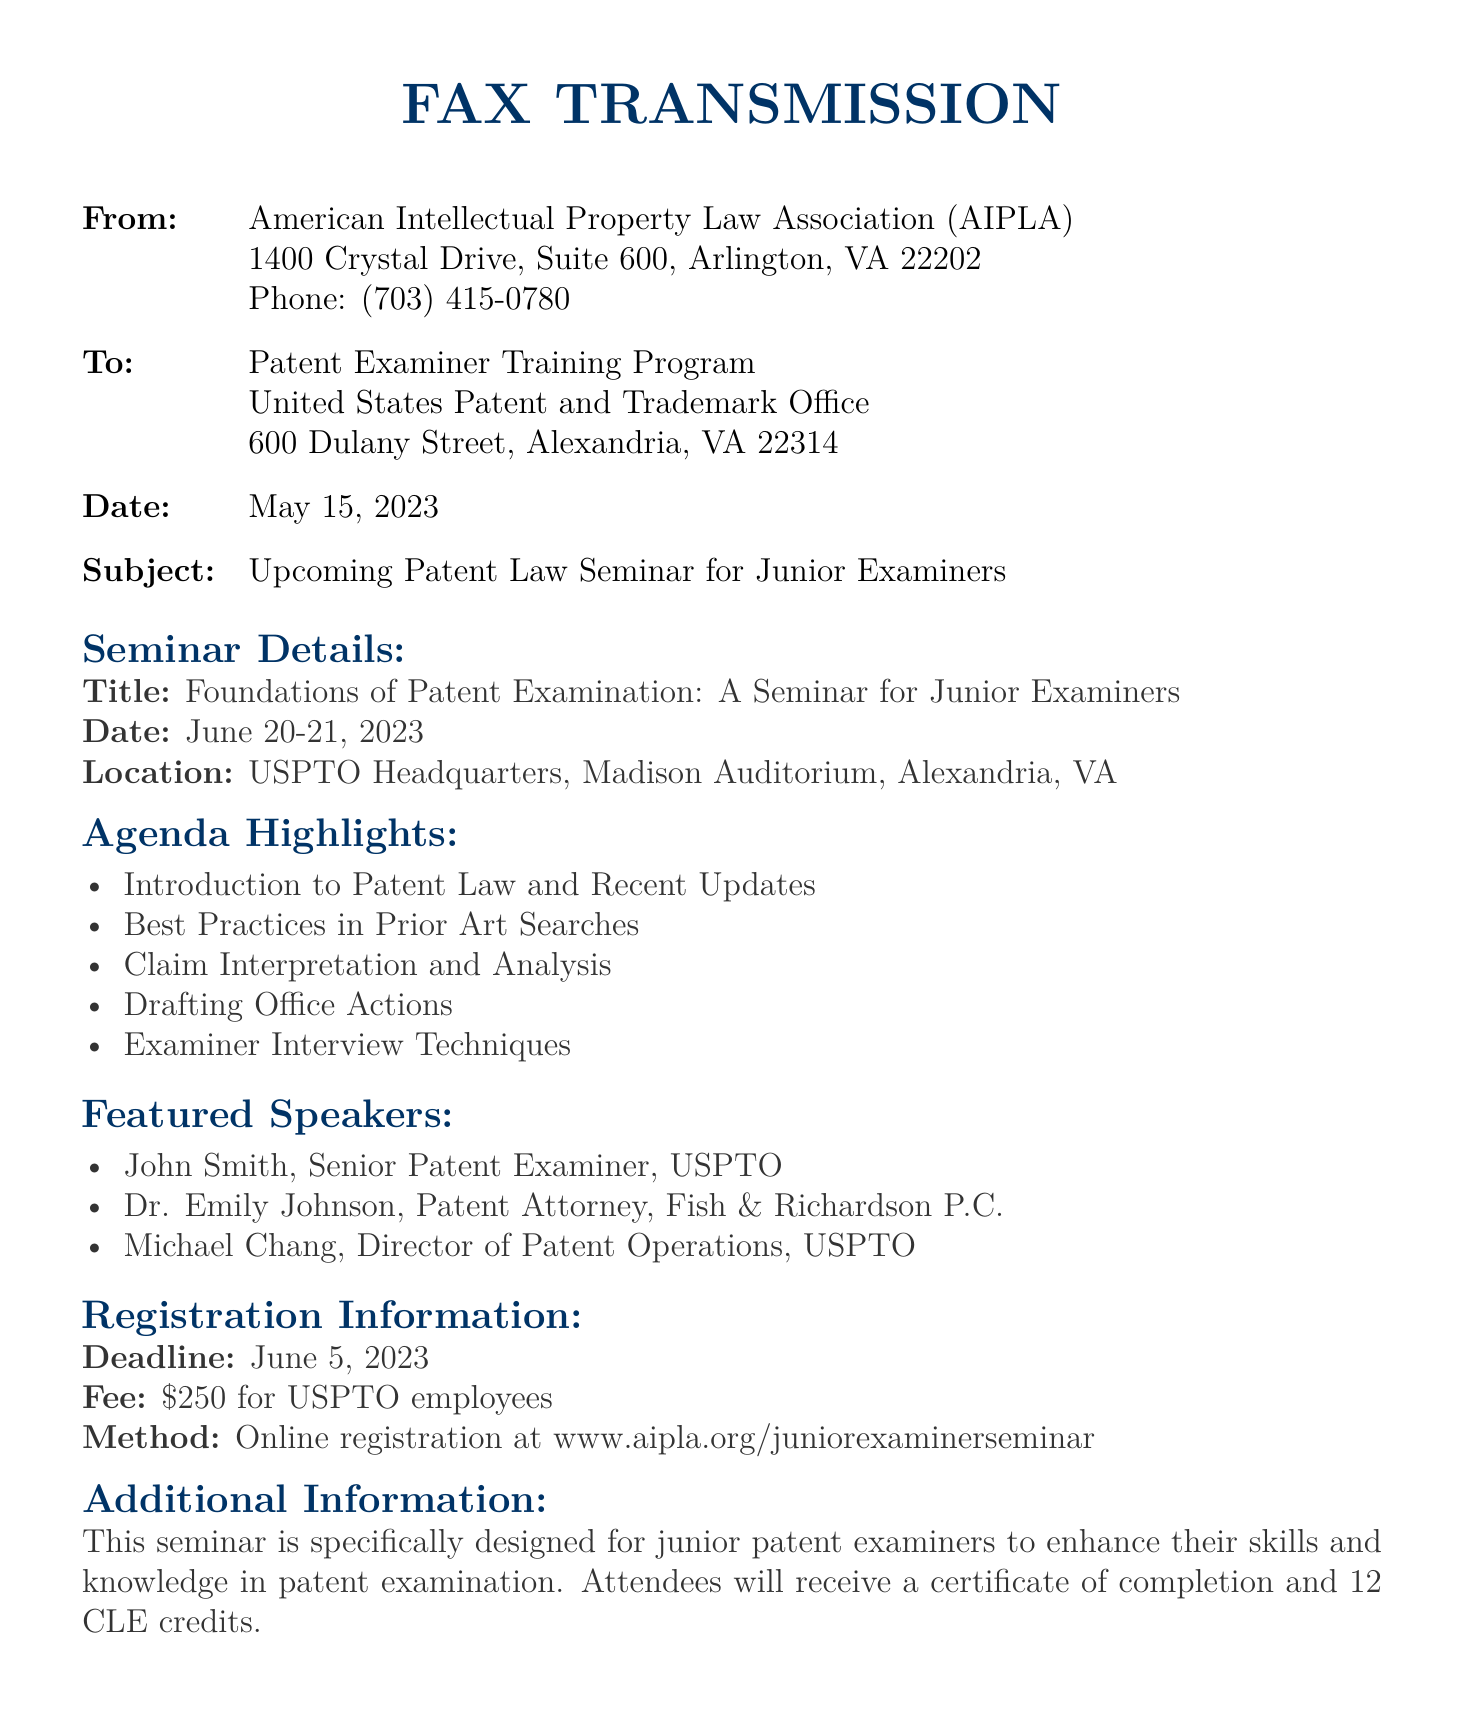What is the title of the seminar? The title of the seminar is found under "Seminar Details," specifically mentioned as "Foundations of Patent Examination: A Seminar for Junior Examiners."
Answer: Foundations of Patent Examination: A Seminar for Junior Examiners What are the dates of the seminar? The seminar dates can be located in the "Seminar Details" section, which states "June 20-21, 2023."
Answer: June 20-21, 2023 What is the registration deadline? The registration deadline is mentioned under "Registration Information," listed as "June 5, 2023."
Answer: June 5, 2023 Who is one of the featured speakers? Featured speakers are listed under "Featured Speakers," where it mentions names such as "John Smith."
Answer: John Smith What is the seminar fee for USPTO employees? The fee for USPTO employees is stated in the "Registration Information" section as "$250."
Answer: $250 What is the main purpose of the seminar? The purpose of the seminar is detailed in the "Additional Information" section, describing it as designed to enhance skills and knowledge in patent examination.
Answer: Enhance skills and knowledge in patent examination How many CLE credits will attendees receive? The number of CLE credits offered to attendees is found in the "Additional Information" section, which states "12 CLE credits."
Answer: 12 CLE credits Where is the seminar location? The location of the seminar is indicated in the "Seminar Details" section as "USPTO Headquarters, Madison Auditorium, Alexandria, VA."
Answer: USPTO Headquarters, Madison Auditorium, Alexandria, VA What is one of the agenda highlights? Agenda highlights include various topics listed in the "Agenda Highlights" section; one example is "Introduction to Patent Law and Recent Updates."
Answer: Introduction to Patent Law and Recent Updates 